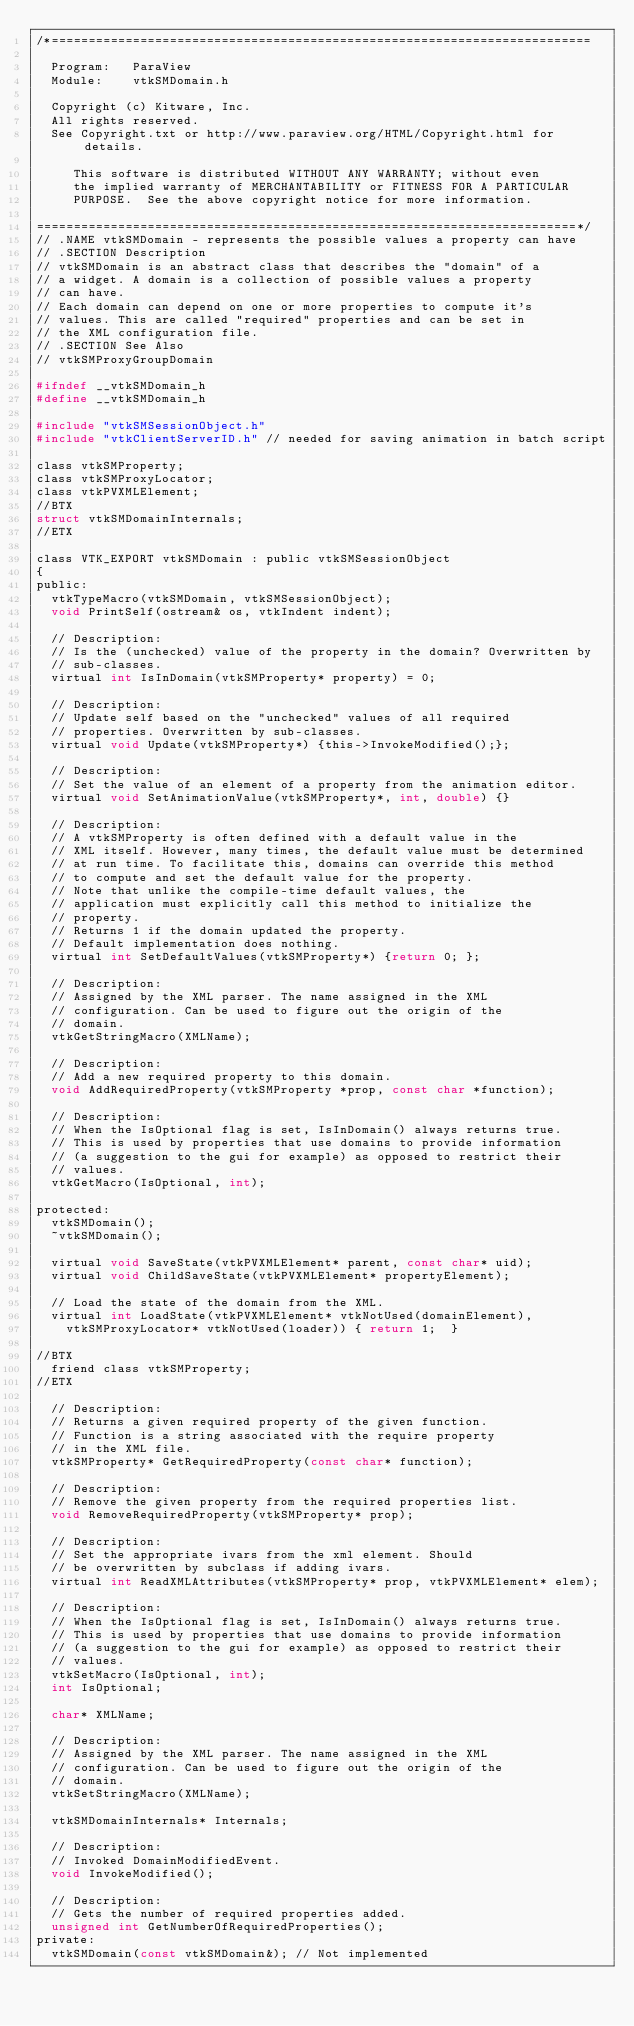Convert code to text. <code><loc_0><loc_0><loc_500><loc_500><_C_>/*=========================================================================

  Program:   ParaView
  Module:    vtkSMDomain.h

  Copyright (c) Kitware, Inc.
  All rights reserved.
  See Copyright.txt or http://www.paraview.org/HTML/Copyright.html for details.

     This software is distributed WITHOUT ANY WARRANTY; without even
     the implied warranty of MERCHANTABILITY or FITNESS FOR A PARTICULAR
     PURPOSE.  See the above copyright notice for more information.

=========================================================================*/
// .NAME vtkSMDomain - represents the possible values a property can have
// .SECTION Description
// vtkSMDomain is an abstract class that describes the "domain" of a
// a widget. A domain is a collection of possible values a property
// can have.
// Each domain can depend on one or more properties to compute it's
// values. This are called "required" properties and can be set in
// the XML configuration file.
// .SECTION See Also
// vtkSMProxyGroupDomain

#ifndef __vtkSMDomain_h
#define __vtkSMDomain_h

#include "vtkSMSessionObject.h"
#include "vtkClientServerID.h" // needed for saving animation in batch script

class vtkSMProperty;
class vtkSMProxyLocator;
class vtkPVXMLElement;
//BTX
struct vtkSMDomainInternals;
//ETX

class VTK_EXPORT vtkSMDomain : public vtkSMSessionObject
{
public:
  vtkTypeMacro(vtkSMDomain, vtkSMSessionObject);
  void PrintSelf(ostream& os, vtkIndent indent);

  // Description:
  // Is the (unchecked) value of the property in the domain? Overwritten by
  // sub-classes.
  virtual int IsInDomain(vtkSMProperty* property) = 0;

  // Description:
  // Update self based on the "unchecked" values of all required
  // properties. Overwritten by sub-classes.
  virtual void Update(vtkSMProperty*) {this->InvokeModified();};

  // Description:
  // Set the value of an element of a property from the animation editor.
  virtual void SetAnimationValue(vtkSMProperty*, int, double) {}

  // Description:
  // A vtkSMProperty is often defined with a default value in the
  // XML itself. However, many times, the default value must be determined
  // at run time. To facilitate this, domains can override this method
  // to compute and set the default value for the property.
  // Note that unlike the compile-time default values, the
  // application must explicitly call this method to initialize the
  // property.
  // Returns 1 if the domain updated the property.
  // Default implementation does nothing.
  virtual int SetDefaultValues(vtkSMProperty*) {return 0; };

  // Description:
  // Assigned by the XML parser. The name assigned in the XML
  // configuration. Can be used to figure out the origin of the
  // domain.
  vtkGetStringMacro(XMLName);

  // Description:
  // Add a new required property to this domain.
  void AddRequiredProperty(vtkSMProperty *prop, const char *function);

  // Description:
  // When the IsOptional flag is set, IsInDomain() always returns true.
  // This is used by properties that use domains to provide information
  // (a suggestion to the gui for example) as opposed to restrict their
  // values.
  vtkGetMacro(IsOptional, int);

protected:
  vtkSMDomain();
  ~vtkSMDomain();

  virtual void SaveState(vtkPVXMLElement* parent, const char* uid);
  virtual void ChildSaveState(vtkPVXMLElement* propertyElement);

  // Load the state of the domain from the XML.
  virtual int LoadState(vtkPVXMLElement* vtkNotUsed(domainElement), 
    vtkSMProxyLocator* vtkNotUsed(loader)) { return 1;  }

//BTX
  friend class vtkSMProperty;
//ETX

  // Description:
  // Returns a given required property of the given function.
  // Function is a string associated with the require property
  // in the XML file.
  vtkSMProperty* GetRequiredProperty(const char* function);

  // Description:
  // Remove the given property from the required properties list.
  void RemoveRequiredProperty(vtkSMProperty* prop);

  // Description:
  // Set the appropriate ivars from the xml element. Should
  // be overwritten by subclass if adding ivars.
  virtual int ReadXMLAttributes(vtkSMProperty* prop, vtkPVXMLElement* elem);

  // Description:
  // When the IsOptional flag is set, IsInDomain() always returns true.
  // This is used by properties that use domains to provide information
  // (a suggestion to the gui for example) as opposed to restrict their
  // values.
  vtkSetMacro(IsOptional, int);
  int IsOptional;

  char* XMLName;

  // Description:
  // Assigned by the XML parser. The name assigned in the XML
  // configuration. Can be used to figure out the origin of the
  // domain.
  vtkSetStringMacro(XMLName);

  vtkSMDomainInternals* Internals;

  // Description:
  // Invoked DomainModifiedEvent.
  void InvokeModified();

  // Description:
  // Gets the number of required properties added.
  unsigned int GetNumberOfRequiredProperties();
private:
  vtkSMDomain(const vtkSMDomain&); // Not implemented</code> 